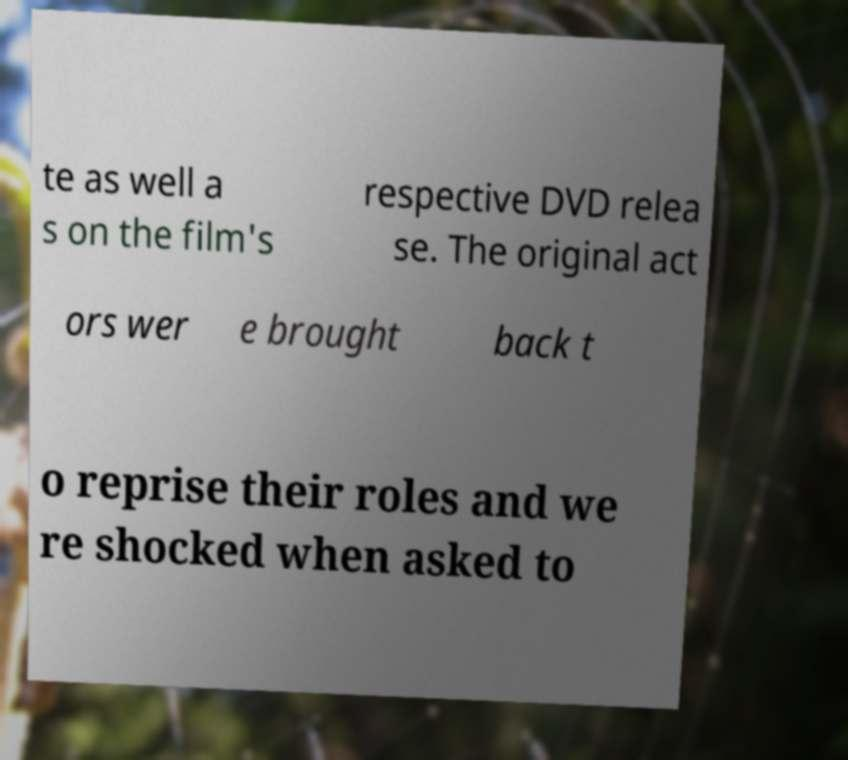Could you extract and type out the text from this image? te as well a s on the film's respective DVD relea se. The original act ors wer e brought back t o reprise their roles and we re shocked when asked to 